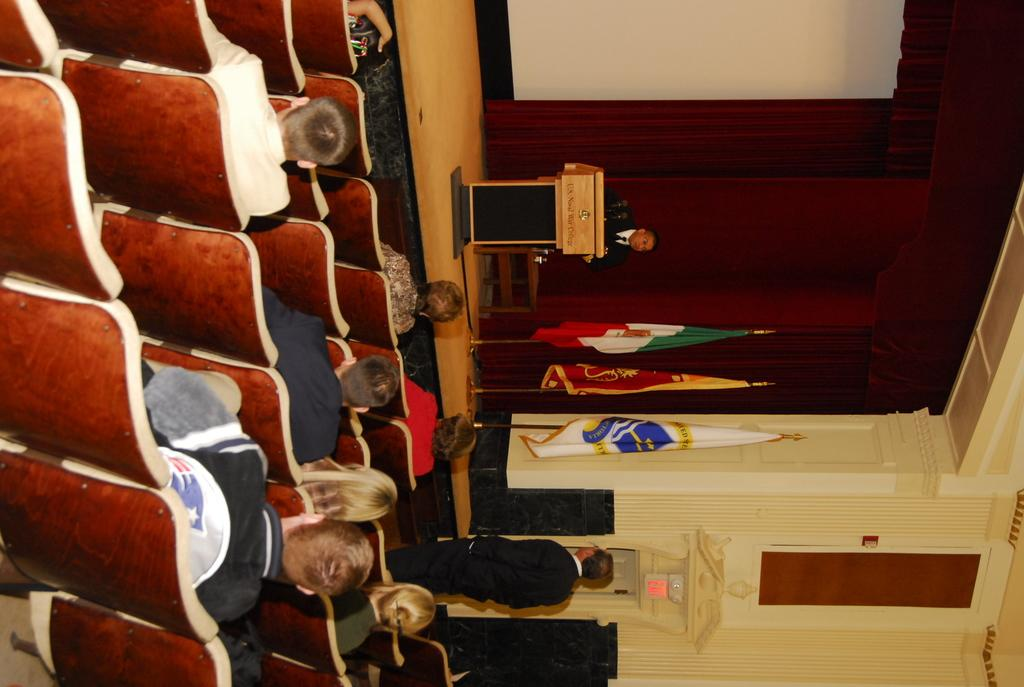What are the people in the image doing? Some people are standing, while others are sitting on chairs. What can be seen in the image besides the people? There are flags, a podium, and a red curtain in the background of the image. What type of bubble can be seen floating near the people in the image? There is no bubble present in the image. What nation is represented by the flags in the image? The flags in the image do not represent any specific nation; they are just flags. 